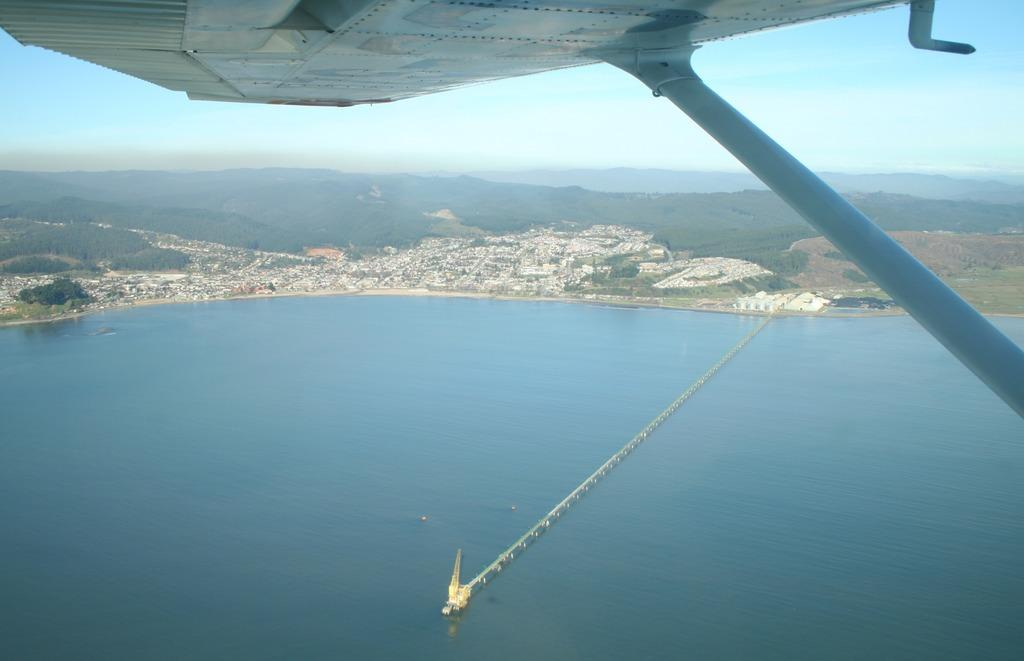What is the rod with a flat surface used for in the image? The rod with a flat surface is likely a bridge, as it is positioned over the water in the image. What is the water in the image used for? The water in the image is likely a river or body of water that the bridge is built over. What can be seen on the water in the image? There is a bridge on the water in the image. What is visible in the background of the image? Hills and the sky are visible in the background of the image. How many letters are floating in the water in the image? There are no letters visible in the image; it features a bridge over water with hills and sky in the background. What type of apples are growing on the hills in the image? There are no apples or trees visible on the hills in the image; only hills and sky are visible in the background. 